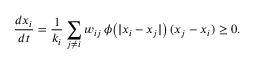Convert formula to latex. <formula><loc_0><loc_0><loc_500><loc_500>\frac { d x _ { i } } { d t } = \frac { 1 } { k _ { i } } \sum _ { j \neq i } w _ { i j } \, \phi \left ( | x _ { i } - x _ { j } | \right ) \, ( x _ { j } - x _ { i } ) \geq 0 .</formula> 